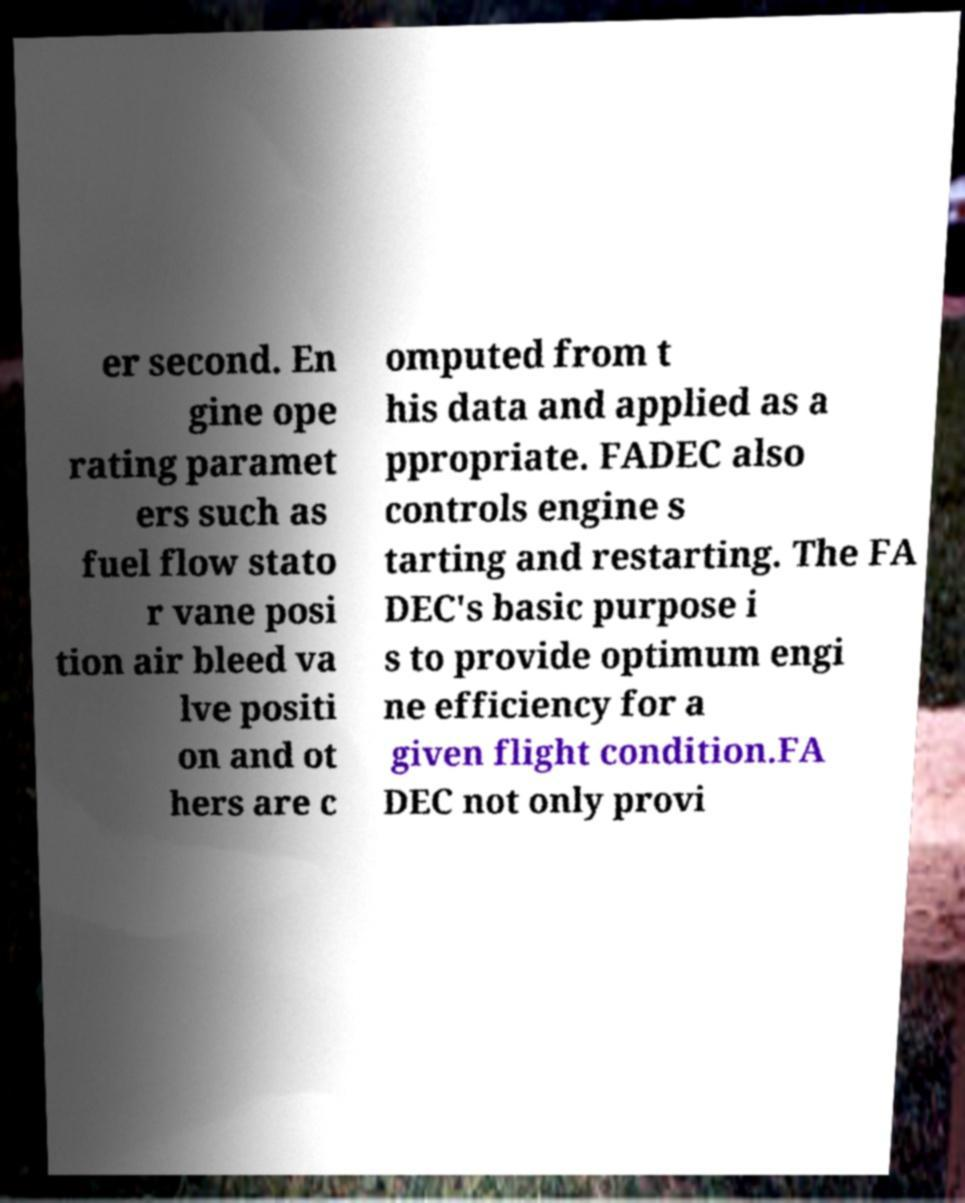Could you assist in decoding the text presented in this image and type it out clearly? er second. En gine ope rating paramet ers such as fuel flow stato r vane posi tion air bleed va lve positi on and ot hers are c omputed from t his data and applied as a ppropriate. FADEC also controls engine s tarting and restarting. The FA DEC's basic purpose i s to provide optimum engi ne efficiency for a given flight condition.FA DEC not only provi 